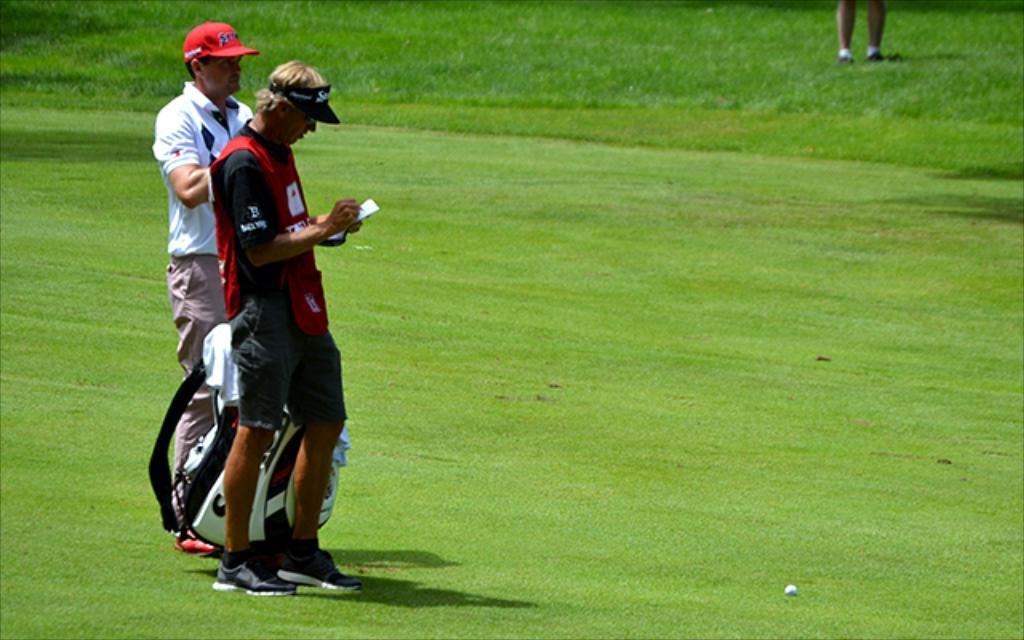Could you give a brief overview of what you see in this image? In this picture I can see there are two men standing here and the person in the backdrop is holding a golf bag and there is another person standing on to right backdrop and there is grass on the floor. 